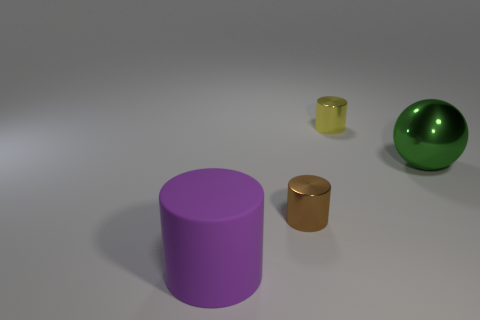Subtract 1 cylinders. How many cylinders are left? 2 Add 4 big matte cylinders. How many objects exist? 8 Subtract all cylinders. How many objects are left? 1 Add 2 green metal things. How many green metal things are left? 3 Add 2 large balls. How many large balls exist? 3 Subtract 0 gray cylinders. How many objects are left? 4 Subtract all yellow shiny cylinders. Subtract all big blue cylinders. How many objects are left? 3 